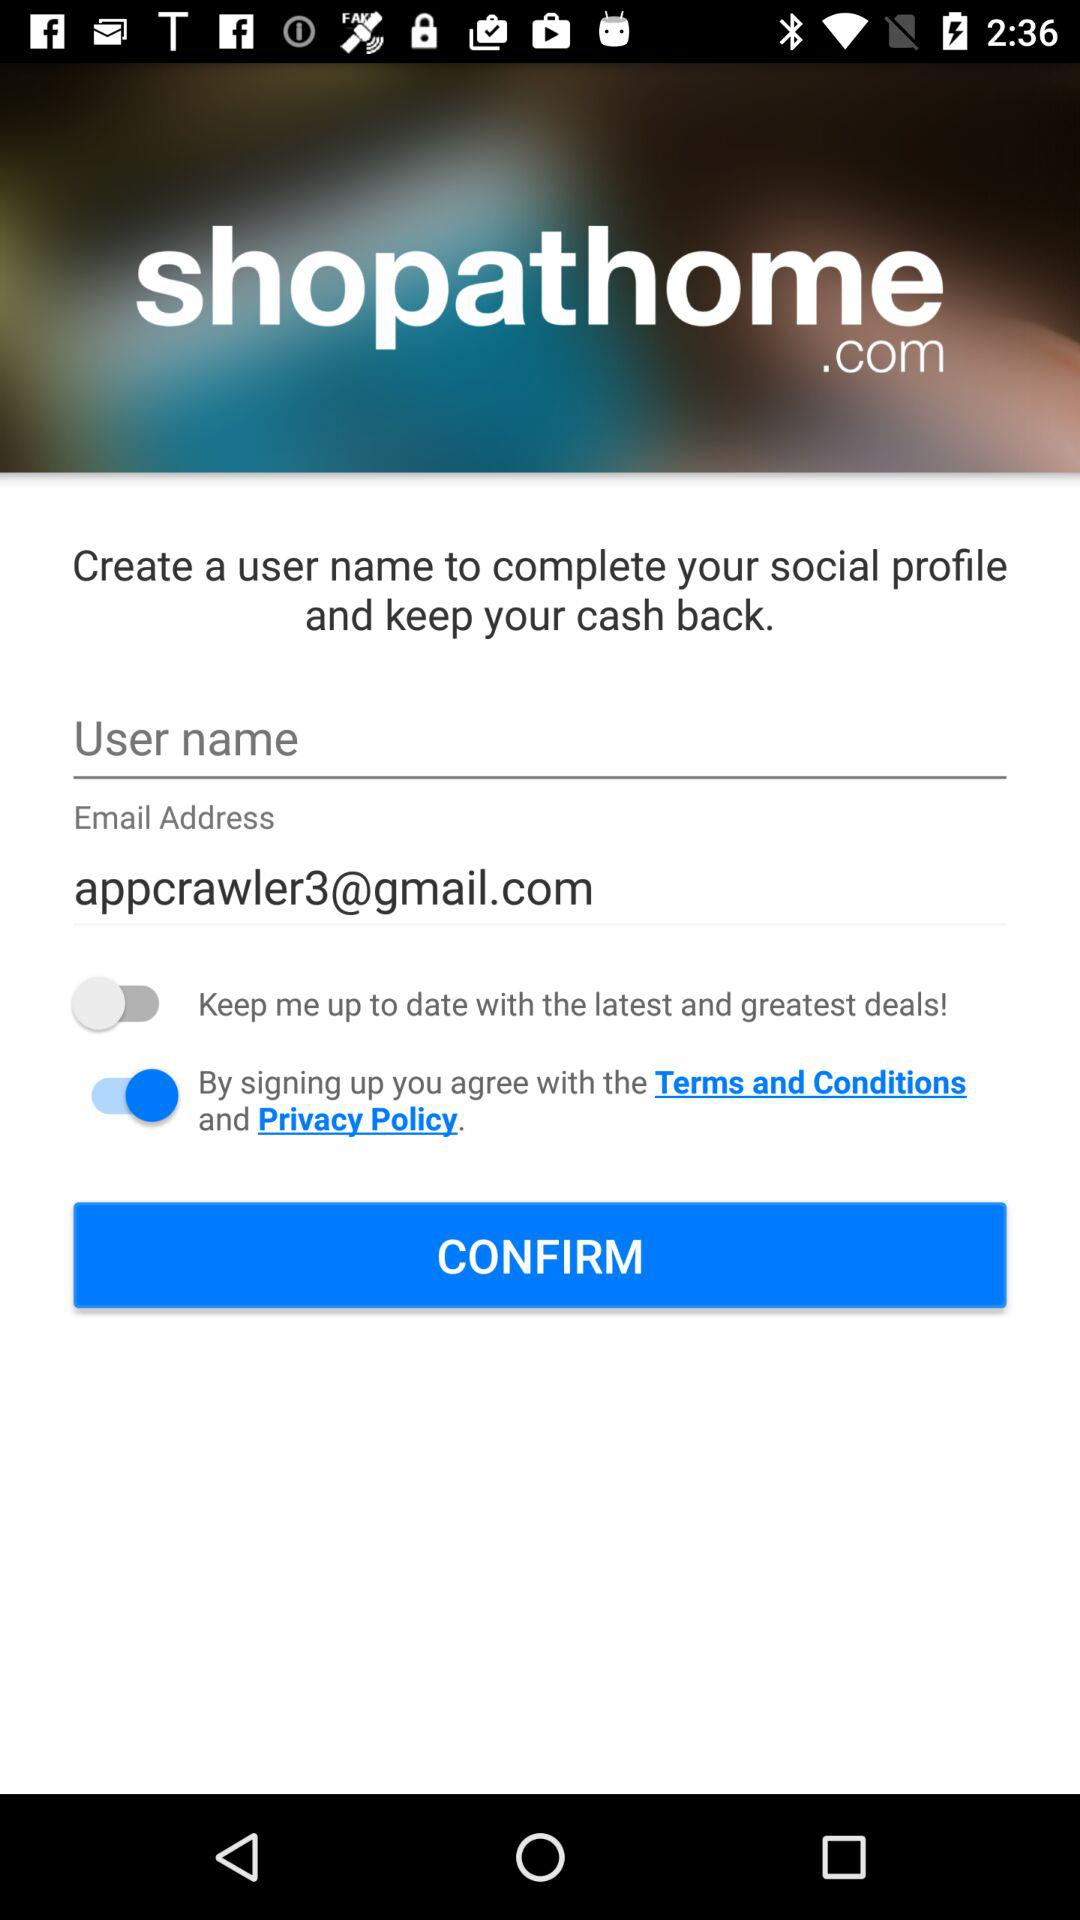What is the status of "keep me up to date with the latest and greatest deals!"? The status is "off". 